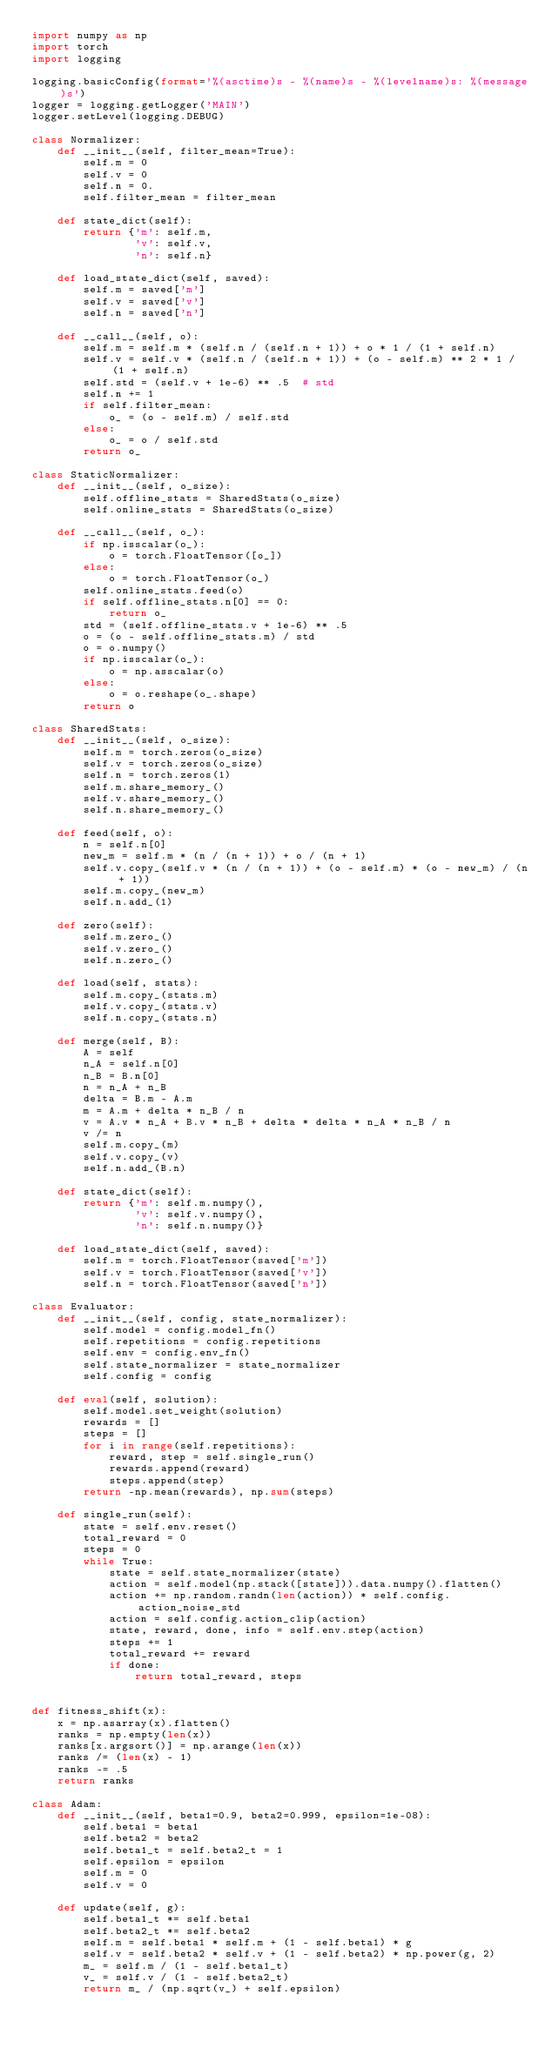<code> <loc_0><loc_0><loc_500><loc_500><_Python_>import numpy as np
import torch
import logging

logging.basicConfig(format='%(asctime)s - %(name)s - %(levelname)s: %(message)s')
logger = logging.getLogger('MAIN')
logger.setLevel(logging.DEBUG)

class Normalizer:
    def __init__(self, filter_mean=True):
        self.m = 0
        self.v = 0
        self.n = 0.
        self.filter_mean = filter_mean

    def state_dict(self):
        return {'m': self.m,
                'v': self.v,
                'n': self.n}

    def load_state_dict(self, saved):
        self.m = saved['m']
        self.v = saved['v']
        self.n = saved['n']

    def __call__(self, o):
        self.m = self.m * (self.n / (self.n + 1)) + o * 1 / (1 + self.n)
        self.v = self.v * (self.n / (self.n + 1)) + (o - self.m) ** 2 * 1 / (1 + self.n)
        self.std = (self.v + 1e-6) ** .5  # std
        self.n += 1
        if self.filter_mean:
            o_ = (o - self.m) / self.std
        else:
            o_ = o / self.std
        return o_

class StaticNormalizer:
    def __init__(self, o_size):
        self.offline_stats = SharedStats(o_size)
        self.online_stats = SharedStats(o_size)

    def __call__(self, o_):
        if np.isscalar(o_):
            o = torch.FloatTensor([o_])
        else:
            o = torch.FloatTensor(o_)
        self.online_stats.feed(o)
        if self.offline_stats.n[0] == 0:
            return o_
        std = (self.offline_stats.v + 1e-6) ** .5
        o = (o - self.offline_stats.m) / std
        o = o.numpy()
        if np.isscalar(o_):
            o = np.asscalar(o)
        else:
            o = o.reshape(o_.shape)
        return o

class SharedStats:
    def __init__(self, o_size):
        self.m = torch.zeros(o_size)
        self.v = torch.zeros(o_size)
        self.n = torch.zeros(1)
        self.m.share_memory_()
        self.v.share_memory_()
        self.n.share_memory_()

    def feed(self, o):
        n = self.n[0]
        new_m = self.m * (n / (n + 1)) + o / (n + 1)
        self.v.copy_(self.v * (n / (n + 1)) + (o - self.m) * (o - new_m) / (n + 1))
        self.m.copy_(new_m)
        self.n.add_(1)

    def zero(self):
        self.m.zero_()
        self.v.zero_()
        self.n.zero_()

    def load(self, stats):
        self.m.copy_(stats.m)
        self.v.copy_(stats.v)
        self.n.copy_(stats.n)

    def merge(self, B):
        A = self
        n_A = self.n[0]
        n_B = B.n[0]
        n = n_A + n_B
        delta = B.m - A.m
        m = A.m + delta * n_B / n
        v = A.v * n_A + B.v * n_B + delta * delta * n_A * n_B / n
        v /= n
        self.m.copy_(m)
        self.v.copy_(v)
        self.n.add_(B.n)

    def state_dict(self):
        return {'m': self.m.numpy(),
                'v': self.v.numpy(),
                'n': self.n.numpy()}

    def load_state_dict(self, saved):
        self.m = torch.FloatTensor(saved['m'])
        self.v = torch.FloatTensor(saved['v'])
        self.n = torch.FloatTensor(saved['n'])

class Evaluator:
    def __init__(self, config, state_normalizer):
        self.model = config.model_fn()
        self.repetitions = config.repetitions
        self.env = config.env_fn()
        self.state_normalizer = state_normalizer
        self.config = config

    def eval(self, solution):
        self.model.set_weight(solution)
        rewards = []
        steps = []
        for i in range(self.repetitions):
            reward, step = self.single_run()
            rewards.append(reward)
            steps.append(step)
        return -np.mean(rewards), np.sum(steps)

    def single_run(self):
        state = self.env.reset()
        total_reward = 0
        steps = 0
        while True:
            state = self.state_normalizer(state)
            action = self.model(np.stack([state])).data.numpy().flatten()
            action += np.random.randn(len(action)) * self.config.action_noise_std
            action = self.config.action_clip(action)
            state, reward, done, info = self.env.step(action)
            steps += 1
            total_reward += reward
            if done:
                return total_reward, steps


def fitness_shift(x):
    x = np.asarray(x).flatten()
    ranks = np.empty(len(x))
    ranks[x.argsort()] = np.arange(len(x))
    ranks /= (len(x) - 1)
    ranks -= .5
    return ranks

class Adam:
    def __init__(self, beta1=0.9, beta2=0.999, epsilon=1e-08):
        self.beta1 = beta1
        self.beta2 = beta2
        self.beta1_t = self.beta2_t = 1
        self.epsilon = epsilon
        self.m = 0
        self.v = 0

    def update(self, g):
        self.beta1_t *= self.beta1
        self.beta2_t *= self.beta2
        self.m = self.beta1 * self.m + (1 - self.beta1) * g
        self.v = self.beta2 * self.v + (1 - self.beta2) * np.power(g, 2)
        m_ = self.m / (1 - self.beta1_t)
        v_ = self.v / (1 - self.beta2_t)
        return m_ / (np.sqrt(v_) + self.epsilon)</code> 